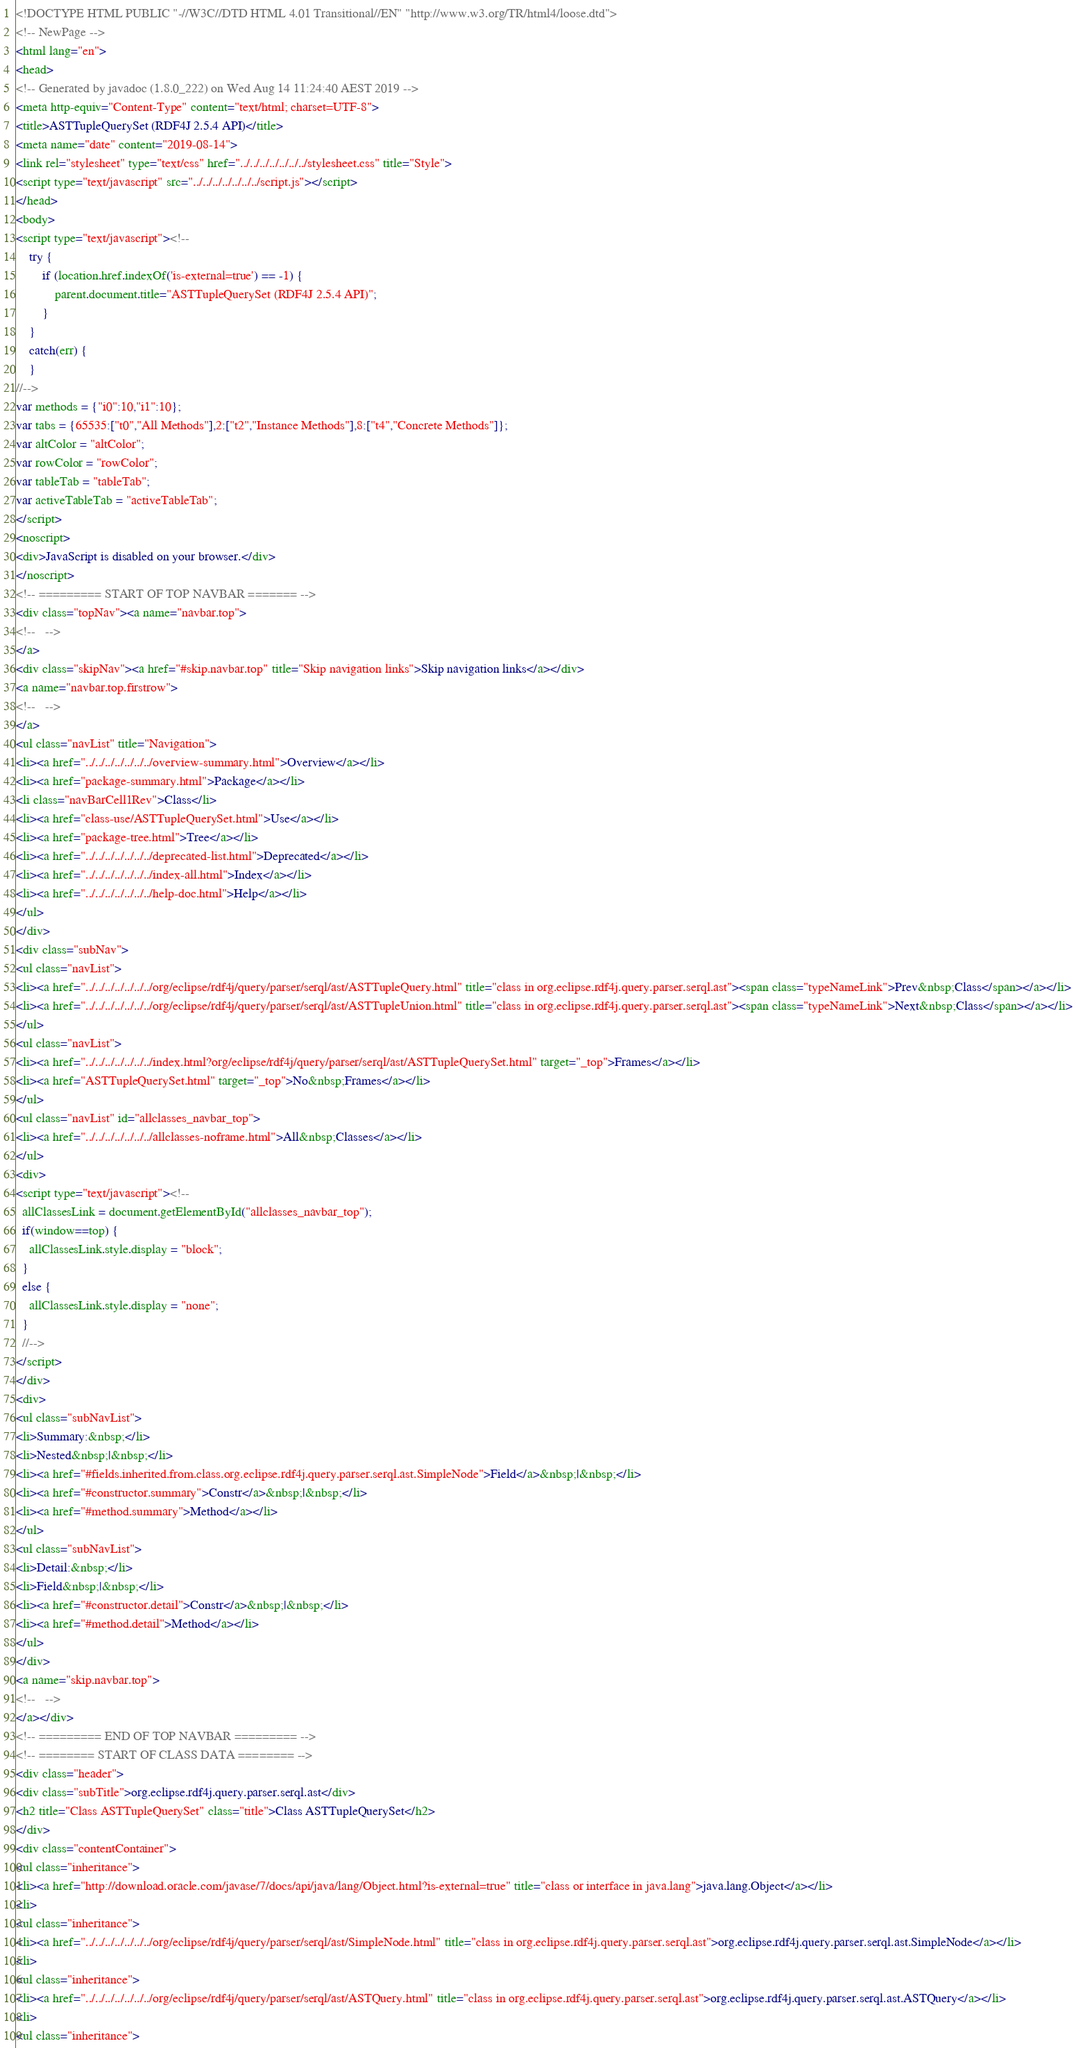Convert code to text. <code><loc_0><loc_0><loc_500><loc_500><_HTML_><!DOCTYPE HTML PUBLIC "-//W3C//DTD HTML 4.01 Transitional//EN" "http://www.w3.org/TR/html4/loose.dtd">
<!-- NewPage -->
<html lang="en">
<head>
<!-- Generated by javadoc (1.8.0_222) on Wed Aug 14 11:24:40 AEST 2019 -->
<meta http-equiv="Content-Type" content="text/html; charset=UTF-8">
<title>ASTTupleQuerySet (RDF4J 2.5.4 API)</title>
<meta name="date" content="2019-08-14">
<link rel="stylesheet" type="text/css" href="../../../../../../../stylesheet.css" title="Style">
<script type="text/javascript" src="../../../../../../../script.js"></script>
</head>
<body>
<script type="text/javascript"><!--
    try {
        if (location.href.indexOf('is-external=true') == -1) {
            parent.document.title="ASTTupleQuerySet (RDF4J 2.5.4 API)";
        }
    }
    catch(err) {
    }
//-->
var methods = {"i0":10,"i1":10};
var tabs = {65535:["t0","All Methods"],2:["t2","Instance Methods"],8:["t4","Concrete Methods"]};
var altColor = "altColor";
var rowColor = "rowColor";
var tableTab = "tableTab";
var activeTableTab = "activeTableTab";
</script>
<noscript>
<div>JavaScript is disabled on your browser.</div>
</noscript>
<!-- ========= START OF TOP NAVBAR ======= -->
<div class="topNav"><a name="navbar.top">
<!--   -->
</a>
<div class="skipNav"><a href="#skip.navbar.top" title="Skip navigation links">Skip navigation links</a></div>
<a name="navbar.top.firstrow">
<!--   -->
</a>
<ul class="navList" title="Navigation">
<li><a href="../../../../../../../overview-summary.html">Overview</a></li>
<li><a href="package-summary.html">Package</a></li>
<li class="navBarCell1Rev">Class</li>
<li><a href="class-use/ASTTupleQuerySet.html">Use</a></li>
<li><a href="package-tree.html">Tree</a></li>
<li><a href="../../../../../../../deprecated-list.html">Deprecated</a></li>
<li><a href="../../../../../../../index-all.html">Index</a></li>
<li><a href="../../../../../../../help-doc.html">Help</a></li>
</ul>
</div>
<div class="subNav">
<ul class="navList">
<li><a href="../../../../../../../org/eclipse/rdf4j/query/parser/serql/ast/ASTTupleQuery.html" title="class in org.eclipse.rdf4j.query.parser.serql.ast"><span class="typeNameLink">Prev&nbsp;Class</span></a></li>
<li><a href="../../../../../../../org/eclipse/rdf4j/query/parser/serql/ast/ASTTupleUnion.html" title="class in org.eclipse.rdf4j.query.parser.serql.ast"><span class="typeNameLink">Next&nbsp;Class</span></a></li>
</ul>
<ul class="navList">
<li><a href="../../../../../../../index.html?org/eclipse/rdf4j/query/parser/serql/ast/ASTTupleQuerySet.html" target="_top">Frames</a></li>
<li><a href="ASTTupleQuerySet.html" target="_top">No&nbsp;Frames</a></li>
</ul>
<ul class="navList" id="allclasses_navbar_top">
<li><a href="../../../../../../../allclasses-noframe.html">All&nbsp;Classes</a></li>
</ul>
<div>
<script type="text/javascript"><!--
  allClassesLink = document.getElementById("allclasses_navbar_top");
  if(window==top) {
    allClassesLink.style.display = "block";
  }
  else {
    allClassesLink.style.display = "none";
  }
  //-->
</script>
</div>
<div>
<ul class="subNavList">
<li>Summary:&nbsp;</li>
<li>Nested&nbsp;|&nbsp;</li>
<li><a href="#fields.inherited.from.class.org.eclipse.rdf4j.query.parser.serql.ast.SimpleNode">Field</a>&nbsp;|&nbsp;</li>
<li><a href="#constructor.summary">Constr</a>&nbsp;|&nbsp;</li>
<li><a href="#method.summary">Method</a></li>
</ul>
<ul class="subNavList">
<li>Detail:&nbsp;</li>
<li>Field&nbsp;|&nbsp;</li>
<li><a href="#constructor.detail">Constr</a>&nbsp;|&nbsp;</li>
<li><a href="#method.detail">Method</a></li>
</ul>
</div>
<a name="skip.navbar.top">
<!--   -->
</a></div>
<!-- ========= END OF TOP NAVBAR ========= -->
<!-- ======== START OF CLASS DATA ======== -->
<div class="header">
<div class="subTitle">org.eclipse.rdf4j.query.parser.serql.ast</div>
<h2 title="Class ASTTupleQuerySet" class="title">Class ASTTupleQuerySet</h2>
</div>
<div class="contentContainer">
<ul class="inheritance">
<li><a href="http://download.oracle.com/javase/7/docs/api/java/lang/Object.html?is-external=true" title="class or interface in java.lang">java.lang.Object</a></li>
<li>
<ul class="inheritance">
<li><a href="../../../../../../../org/eclipse/rdf4j/query/parser/serql/ast/SimpleNode.html" title="class in org.eclipse.rdf4j.query.parser.serql.ast">org.eclipse.rdf4j.query.parser.serql.ast.SimpleNode</a></li>
<li>
<ul class="inheritance">
<li><a href="../../../../../../../org/eclipse/rdf4j/query/parser/serql/ast/ASTQuery.html" title="class in org.eclipse.rdf4j.query.parser.serql.ast">org.eclipse.rdf4j.query.parser.serql.ast.ASTQuery</a></li>
<li>
<ul class="inheritance"></code> 